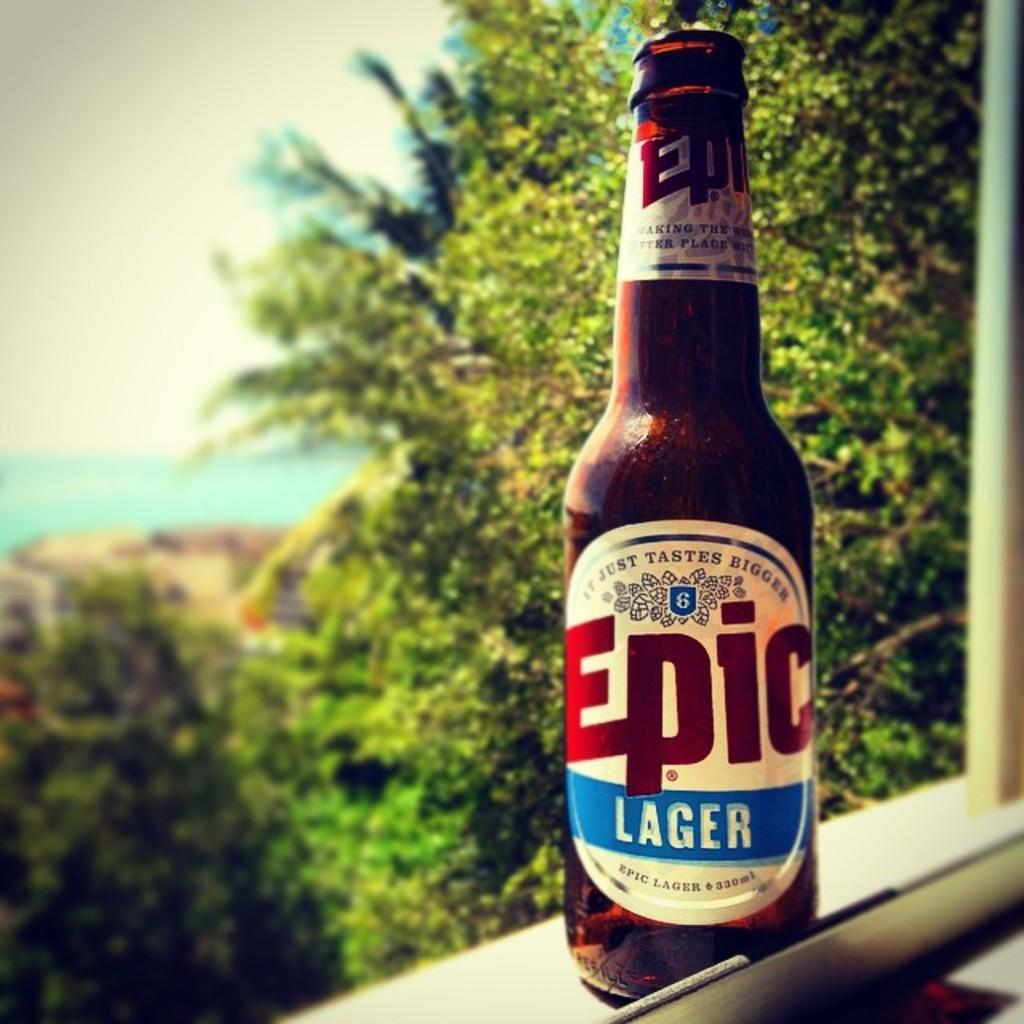Provide a one-sentence caption for the provided image. A bottle of Epic Lager sits on a windowsill on a beautiful day. 